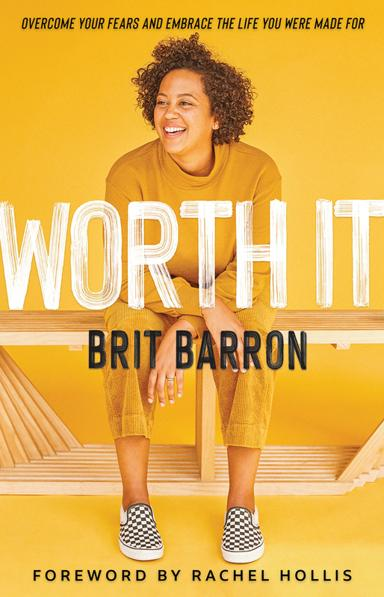Who wrote the foreword for this book? The foreword of the book "Worth It" is penned by Rachel Hollis, a renowned author herself. Rachel's contribution is likely to add a persuasive and inspiring prelude to Brit Barron's narratives on overcoming personal obstacles and self-doubt. 